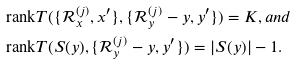Convert formula to latex. <formula><loc_0><loc_0><loc_500><loc_500>& \text {rank} T ( \{ \mathcal { R } ^ { ( j ) } _ { x } , x ^ { \prime } \} , \{ \mathcal { R } ^ { ( j ) } _ { y } - y , y ^ { \prime } \} ) = K , a n d \\ & \text {rank} T ( S ( y ) , \{ \mathcal { R } ^ { ( j ) } _ { y } - y , y ^ { \prime } \} ) = | S ( y ) | - 1 .</formula> 